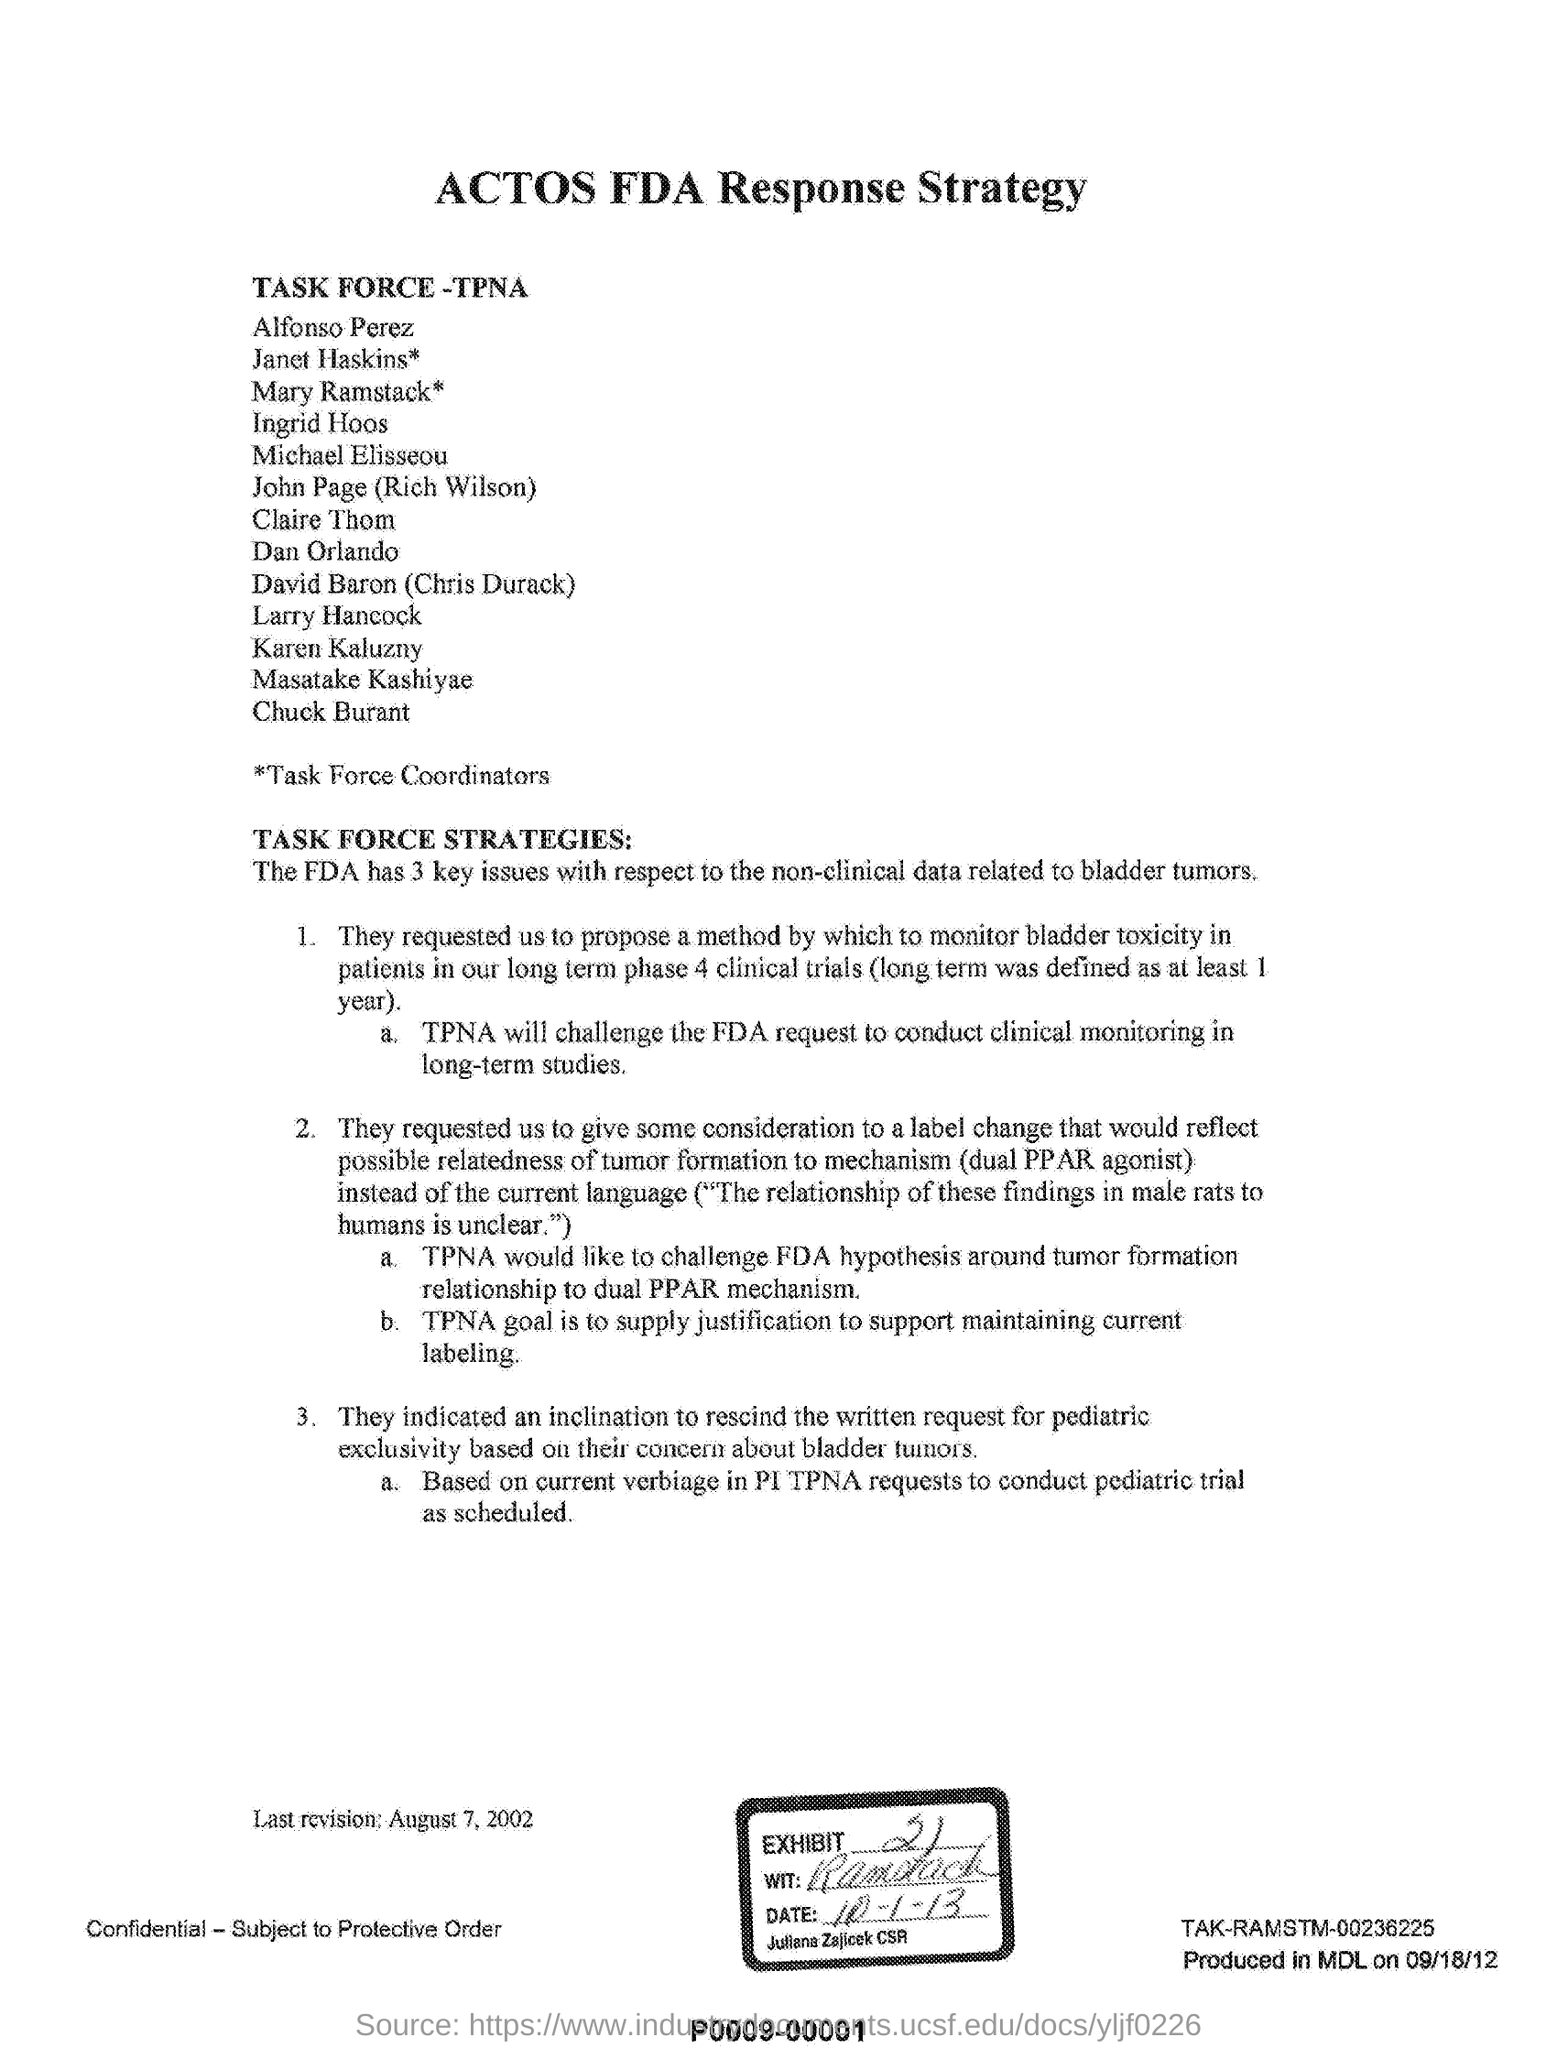What is the heading of this document?
Keep it short and to the point. ACTOS FDA Response Strategy. What is the last revision date mentioned in this document?
Your response must be concise. August 7, 2002. What is the goal of TPNA?
Your answer should be very brief. To supply justification to support maintaining current labeling. 